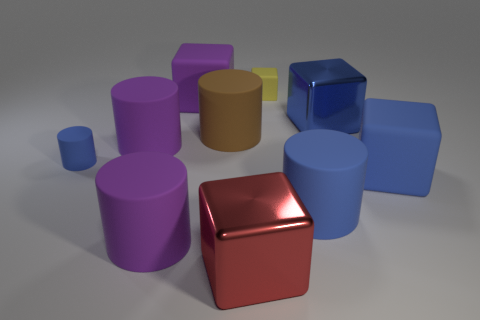Subtract all yellow blocks. How many blocks are left? 4 Subtract all purple blocks. How many blocks are left? 4 Subtract all red blocks. Subtract all blue spheres. How many blocks are left? 4 Add 1 metallic things. How many metallic things exist? 3 Subtract 0 green cylinders. How many objects are left? 10 Subtract all purple objects. Subtract all tiny yellow matte blocks. How many objects are left? 6 Add 1 cubes. How many cubes are left? 6 